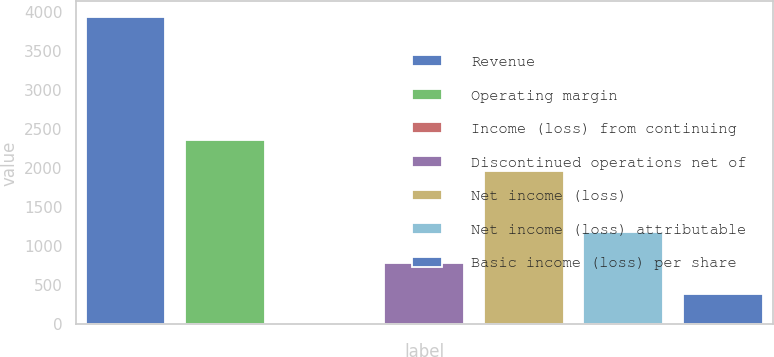Convert chart to OTSL. <chart><loc_0><loc_0><loc_500><loc_500><bar_chart><fcel>Revenue<fcel>Operating margin<fcel>Income (loss) from continuing<fcel>Discontinued operations net of<fcel>Net income (loss)<fcel>Net income (loss) attributable<fcel>Basic income (loss) per share<nl><fcel>3943<fcel>2365.9<fcel>0.22<fcel>788.78<fcel>1971.62<fcel>1183.06<fcel>394.5<nl></chart> 